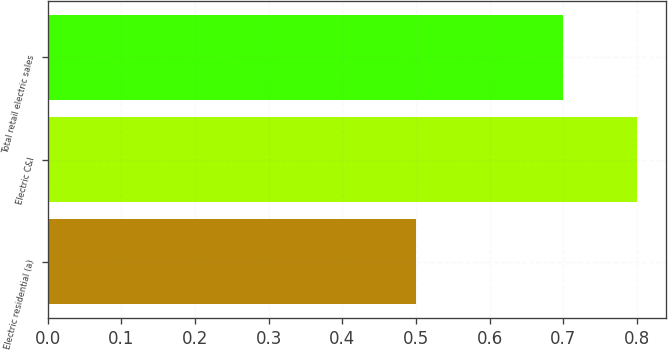Convert chart. <chart><loc_0><loc_0><loc_500><loc_500><bar_chart><fcel>Electric residential (a)<fcel>Electric C&I<fcel>Total retail electric sales<nl><fcel>0.5<fcel>0.8<fcel>0.7<nl></chart> 